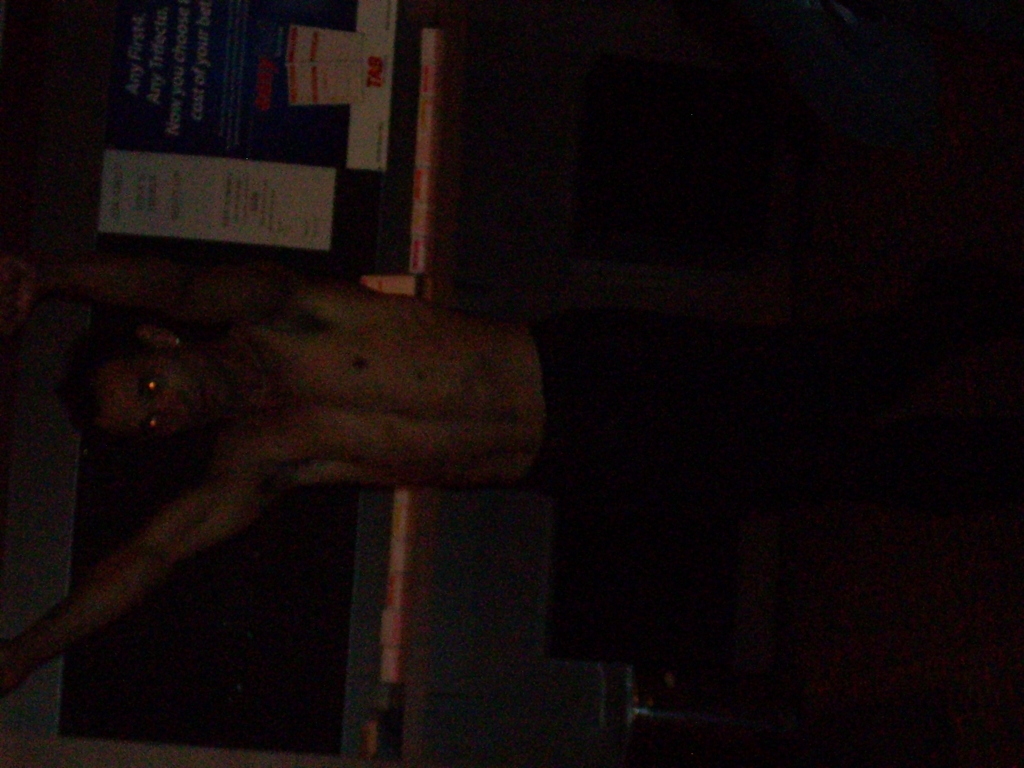What can you say about the details in the dark areas of this photo?
A. The photo has completely lost details in the dark areas.
B. The photo has some details in the dark areas.
C. The photo has average details in the dark areas. While the photo is predominantly dark, upon closer inspection, there are subtle nuances and some details within the darker regions. It is difficult to discern specific characteristics clearly due to the low lighting, but it's not accurate to say that it has completely lost details. There is enough visible information to suggest that some delicate details can still be perceived, especially nearer to the areas with better illumination. 